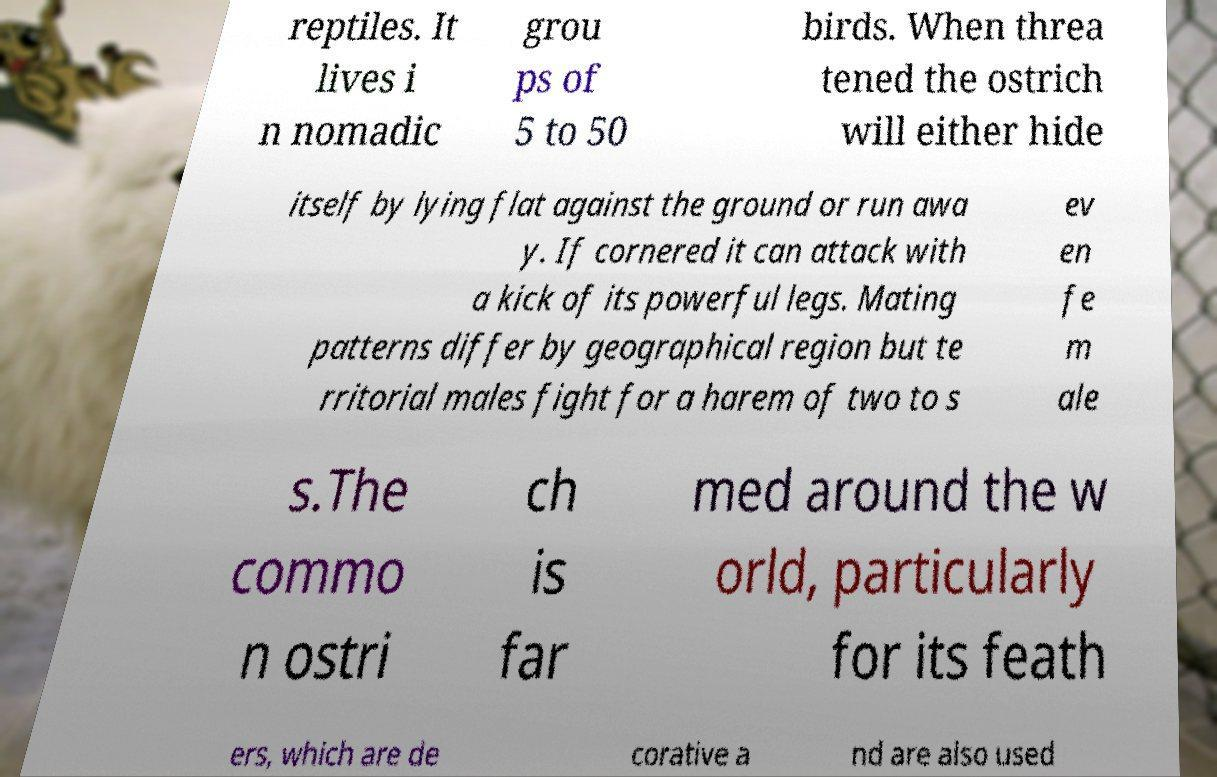Can you read and provide the text displayed in the image?This photo seems to have some interesting text. Can you extract and type it out for me? reptiles. It lives i n nomadic grou ps of 5 to 50 birds. When threa tened the ostrich will either hide itself by lying flat against the ground or run awa y. If cornered it can attack with a kick of its powerful legs. Mating patterns differ by geographical region but te rritorial males fight for a harem of two to s ev en fe m ale s.The commo n ostri ch is far med around the w orld, particularly for its feath ers, which are de corative a nd are also used 